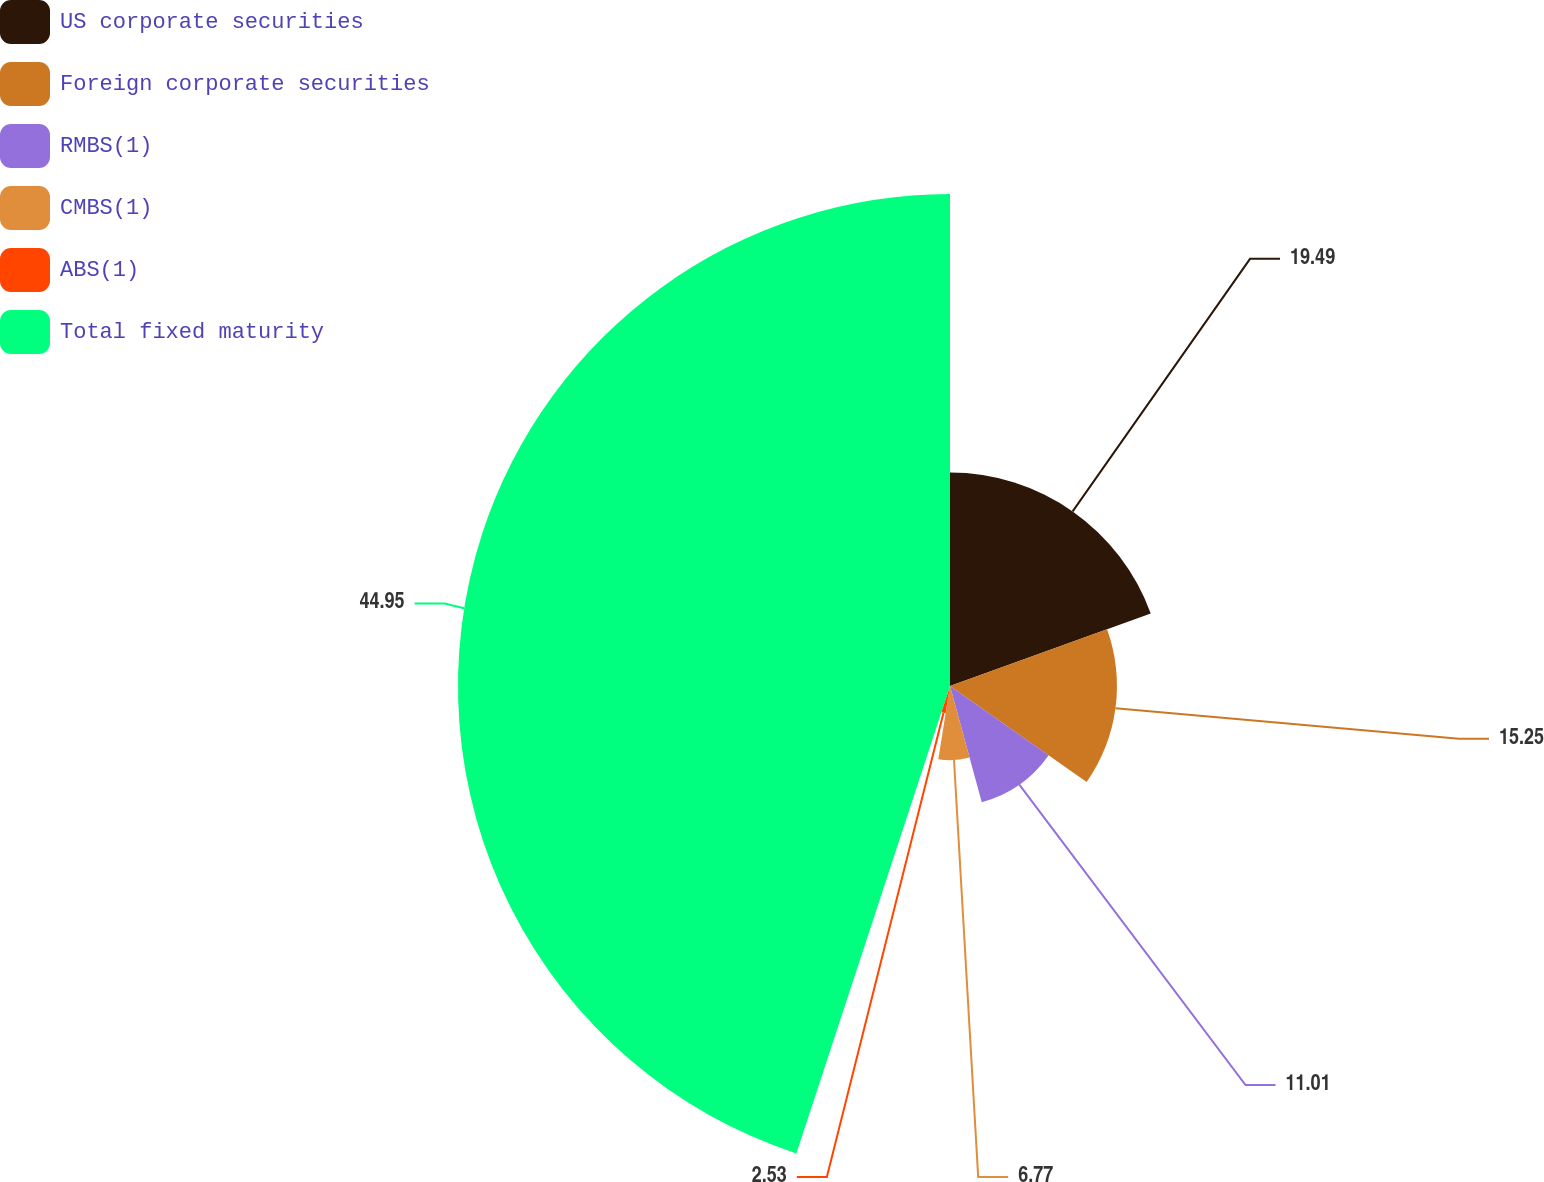Convert chart. <chart><loc_0><loc_0><loc_500><loc_500><pie_chart><fcel>US corporate securities<fcel>Foreign corporate securities<fcel>RMBS(1)<fcel>CMBS(1)<fcel>ABS(1)<fcel>Total fixed maturity<nl><fcel>19.49%<fcel>15.25%<fcel>11.01%<fcel>6.77%<fcel>2.53%<fcel>44.94%<nl></chart> 